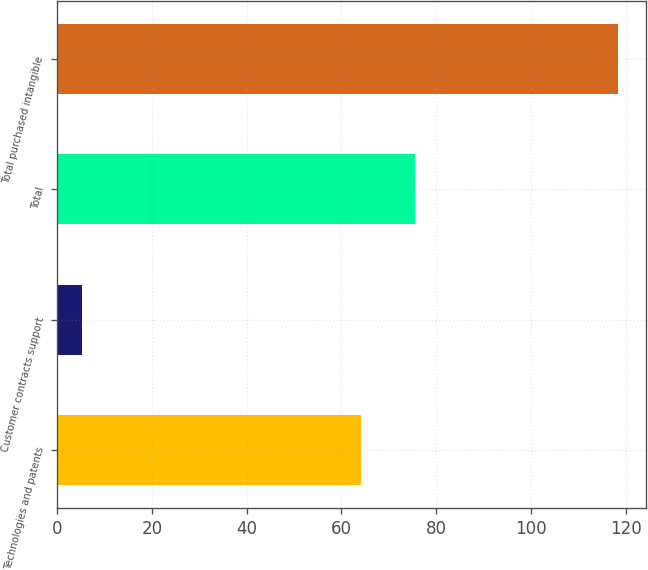<chart> <loc_0><loc_0><loc_500><loc_500><bar_chart><fcel>Technologies and patents<fcel>Customer contracts support<fcel>Total<fcel>Total purchased intangible<nl><fcel>64.2<fcel>5.3<fcel>75.52<fcel>118.5<nl></chart> 